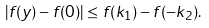Convert formula to latex. <formula><loc_0><loc_0><loc_500><loc_500>| f ( y ) - f ( 0 ) | \leq f ( k _ { 1 } ) - f ( - k _ { 2 } ) .</formula> 